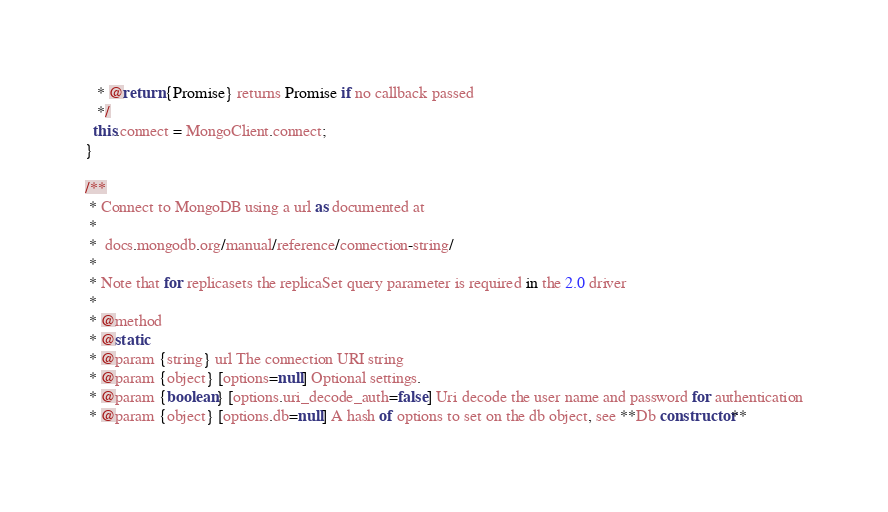<code> <loc_0><loc_0><loc_500><loc_500><_JavaScript_>   * @return {Promise} returns Promise if no callback passed
   */
  this.connect = MongoClient.connect;
}

/**
 * Connect to MongoDB using a url as documented at
 *
 *  docs.mongodb.org/manual/reference/connection-string/
 *
 * Note that for replicasets the replicaSet query parameter is required in the 2.0 driver
 *
 * @method
 * @static
 * @param {string} url The connection URI string
 * @param {object} [options=null] Optional settings.
 * @param {boolean} [options.uri_decode_auth=false] Uri decode the user name and password for authentication
 * @param {object} [options.db=null] A hash of options to set on the db object, see **Db constructor**</code> 